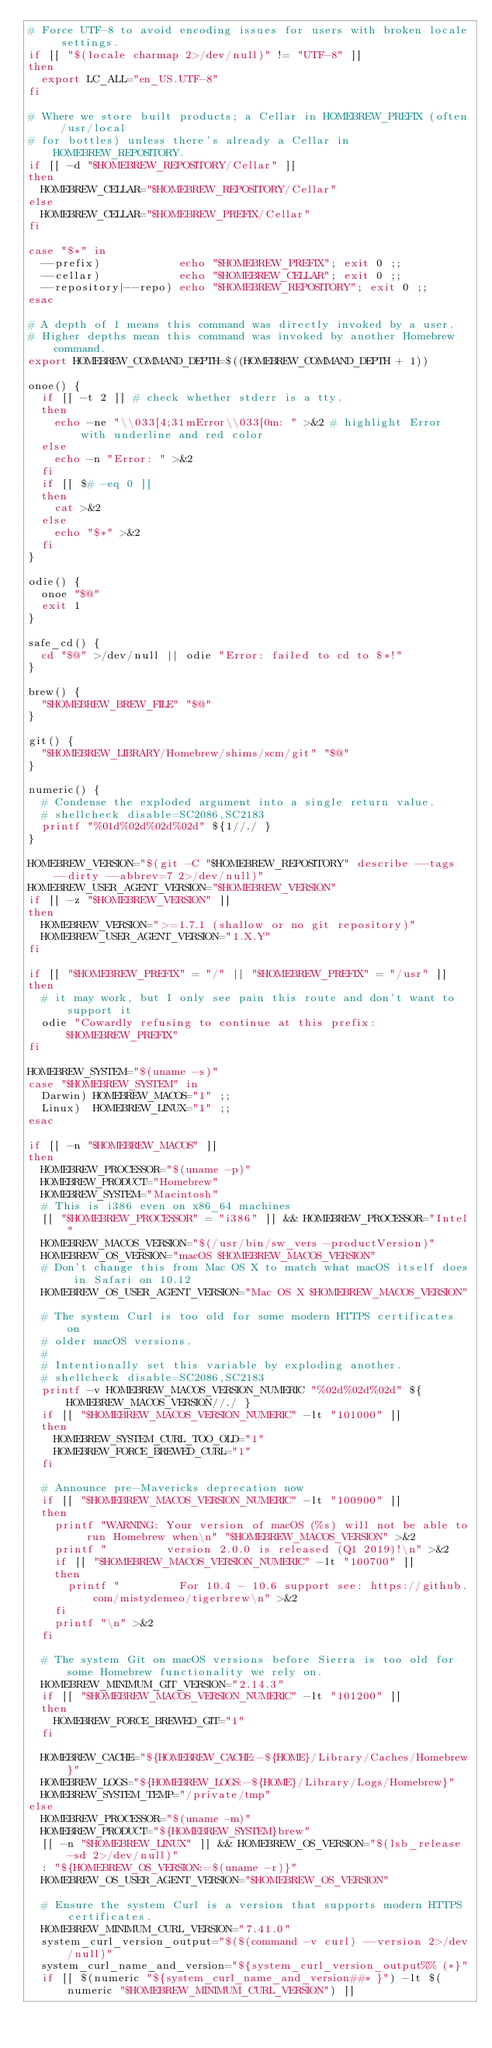Convert code to text. <code><loc_0><loc_0><loc_500><loc_500><_Bash_># Force UTF-8 to avoid encoding issues for users with broken locale settings.
if [[ "$(locale charmap 2>/dev/null)" != "UTF-8" ]]
then
  export LC_ALL="en_US.UTF-8"
fi

# Where we store built products; a Cellar in HOMEBREW_PREFIX (often /usr/local
# for bottles) unless there's already a Cellar in HOMEBREW_REPOSITORY.
if [[ -d "$HOMEBREW_REPOSITORY/Cellar" ]]
then
  HOMEBREW_CELLAR="$HOMEBREW_REPOSITORY/Cellar"
else
  HOMEBREW_CELLAR="$HOMEBREW_PREFIX/Cellar"
fi

case "$*" in
  --prefix)            echo "$HOMEBREW_PREFIX"; exit 0 ;;
  --cellar)            echo "$HOMEBREW_CELLAR"; exit 0 ;;
  --repository|--repo) echo "$HOMEBREW_REPOSITORY"; exit 0 ;;
esac

# A depth of 1 means this command was directly invoked by a user.
# Higher depths mean this command was invoked by another Homebrew command.
export HOMEBREW_COMMAND_DEPTH=$((HOMEBREW_COMMAND_DEPTH + 1))

onoe() {
  if [[ -t 2 ]] # check whether stderr is a tty.
  then
    echo -ne "\\033[4;31mError\\033[0m: " >&2 # highlight Error with underline and red color
  else
    echo -n "Error: " >&2
  fi
  if [[ $# -eq 0 ]]
  then
    cat >&2
  else
    echo "$*" >&2
  fi
}

odie() {
  onoe "$@"
  exit 1
}

safe_cd() {
  cd "$@" >/dev/null || odie "Error: failed to cd to $*!"
}

brew() {
  "$HOMEBREW_BREW_FILE" "$@"
}

git() {
  "$HOMEBREW_LIBRARY/Homebrew/shims/scm/git" "$@"
}

numeric() {
  # Condense the exploded argument into a single return value.
  # shellcheck disable=SC2086,SC2183
  printf "%01d%02d%02d%02d" ${1//./ }
}

HOMEBREW_VERSION="$(git -C "$HOMEBREW_REPOSITORY" describe --tags --dirty --abbrev=7 2>/dev/null)"
HOMEBREW_USER_AGENT_VERSION="$HOMEBREW_VERSION"
if [[ -z "$HOMEBREW_VERSION" ]]
then
  HOMEBREW_VERSION=">=1.7.1 (shallow or no git repository)"
  HOMEBREW_USER_AGENT_VERSION="1.X.Y"
fi

if [[ "$HOMEBREW_PREFIX" = "/" || "$HOMEBREW_PREFIX" = "/usr" ]]
then
  # it may work, but I only see pain this route and don't want to support it
  odie "Cowardly refusing to continue at this prefix: $HOMEBREW_PREFIX"
fi

HOMEBREW_SYSTEM="$(uname -s)"
case "$HOMEBREW_SYSTEM" in
  Darwin) HOMEBREW_MACOS="1" ;;
  Linux)  HOMEBREW_LINUX="1" ;;
esac

if [[ -n "$HOMEBREW_MACOS" ]]
then
  HOMEBREW_PROCESSOR="$(uname -p)"
  HOMEBREW_PRODUCT="Homebrew"
  HOMEBREW_SYSTEM="Macintosh"
  # This is i386 even on x86_64 machines
  [[ "$HOMEBREW_PROCESSOR" = "i386" ]] && HOMEBREW_PROCESSOR="Intel"
  HOMEBREW_MACOS_VERSION="$(/usr/bin/sw_vers -productVersion)"
  HOMEBREW_OS_VERSION="macOS $HOMEBREW_MACOS_VERSION"
  # Don't change this from Mac OS X to match what macOS itself does in Safari on 10.12
  HOMEBREW_OS_USER_AGENT_VERSION="Mac OS X $HOMEBREW_MACOS_VERSION"

  # The system Curl is too old for some modern HTTPS certificates on
  # older macOS versions.
  #
  # Intentionally set this variable by exploding another.
  # shellcheck disable=SC2086,SC2183
  printf -v HOMEBREW_MACOS_VERSION_NUMERIC "%02d%02d%02d" ${HOMEBREW_MACOS_VERSION//./ }
  if [[ "$HOMEBREW_MACOS_VERSION_NUMERIC" -lt "101000" ]]
  then
    HOMEBREW_SYSTEM_CURL_TOO_OLD="1"
    HOMEBREW_FORCE_BREWED_CURL="1"
  fi

  # Announce pre-Mavericks deprecation now
  if [[ "$HOMEBREW_MACOS_VERSION_NUMERIC" -lt "100900" ]]
  then
    printf "WARNING: Your version of macOS (%s) will not be able to run Homebrew when\n" "$HOMEBREW_MACOS_VERSION" >&2
    printf "         version 2.0.0 is released (Q1 2019)!\n" >&2
    if [[ "$HOMEBREW_MACOS_VERSION_NUMERIC" -lt "100700" ]]
    then
      printf "         For 10.4 - 10.6 support see: https://github.com/mistydemeo/tigerbrew\n" >&2
    fi
    printf "\n" >&2
  fi

  # The system Git on macOS versions before Sierra is too old for some Homebrew functionality we rely on.
  HOMEBREW_MINIMUM_GIT_VERSION="2.14.3"
  if [[ "$HOMEBREW_MACOS_VERSION_NUMERIC" -lt "101200" ]]
  then
    HOMEBREW_FORCE_BREWED_GIT="1"
  fi

  HOMEBREW_CACHE="${HOMEBREW_CACHE:-${HOME}/Library/Caches/Homebrew}"
  HOMEBREW_LOGS="${HOMEBREW_LOGS:-${HOME}/Library/Logs/Homebrew}"
  HOMEBREW_SYSTEM_TEMP="/private/tmp"
else
  HOMEBREW_PROCESSOR="$(uname -m)"
  HOMEBREW_PRODUCT="${HOMEBREW_SYSTEM}brew"
  [[ -n "$HOMEBREW_LINUX" ]] && HOMEBREW_OS_VERSION="$(lsb_release -sd 2>/dev/null)"
  : "${HOMEBREW_OS_VERSION:=$(uname -r)}"
  HOMEBREW_OS_USER_AGENT_VERSION="$HOMEBREW_OS_VERSION"

  # Ensure the system Curl is a version that supports modern HTTPS certificates.
  HOMEBREW_MINIMUM_CURL_VERSION="7.41.0"
  system_curl_version_output="$($(command -v curl) --version 2>/dev/null)"
  system_curl_name_and_version="${system_curl_version_output%% (*}"
  if [[ $(numeric "${system_curl_name_and_version##* }") -lt $(numeric "$HOMEBREW_MINIMUM_CURL_VERSION") ]]</code> 